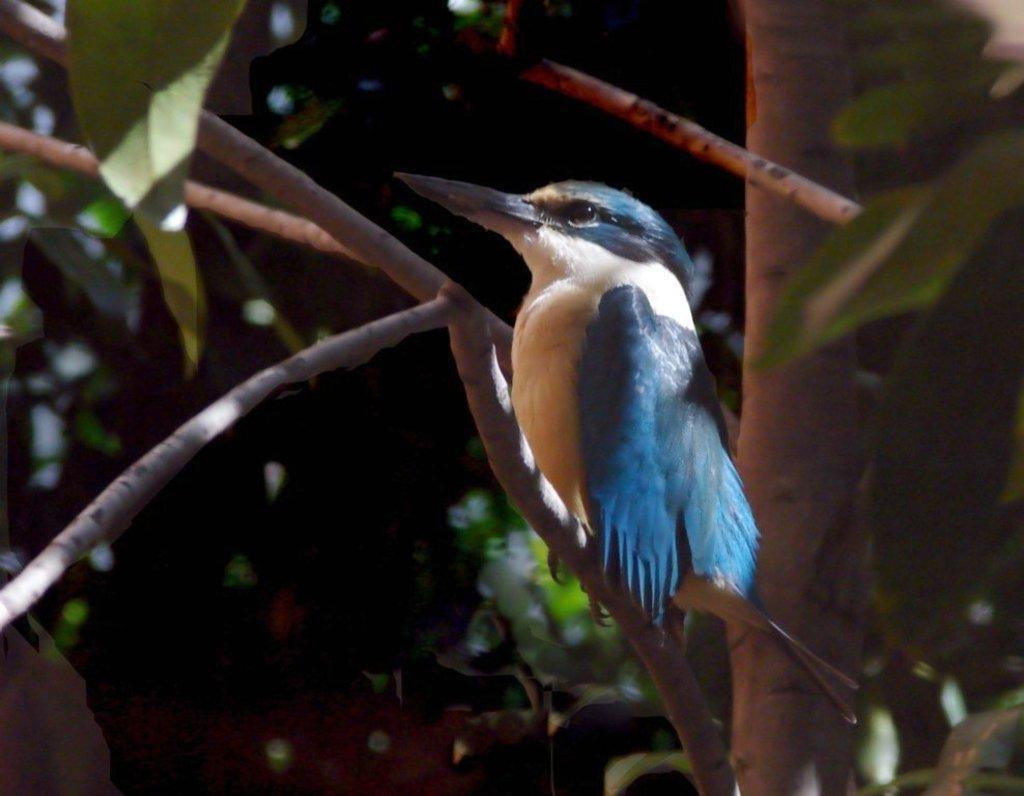Describe this image in one or two sentences. In the image on a tree there is a bird. The bird is blue and white in color. In the background there are trees. 